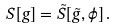Convert formula to latex. <formula><loc_0><loc_0><loc_500><loc_500>S [ g ] = \tilde { S } [ \tilde { g } , \phi ] \, .</formula> 